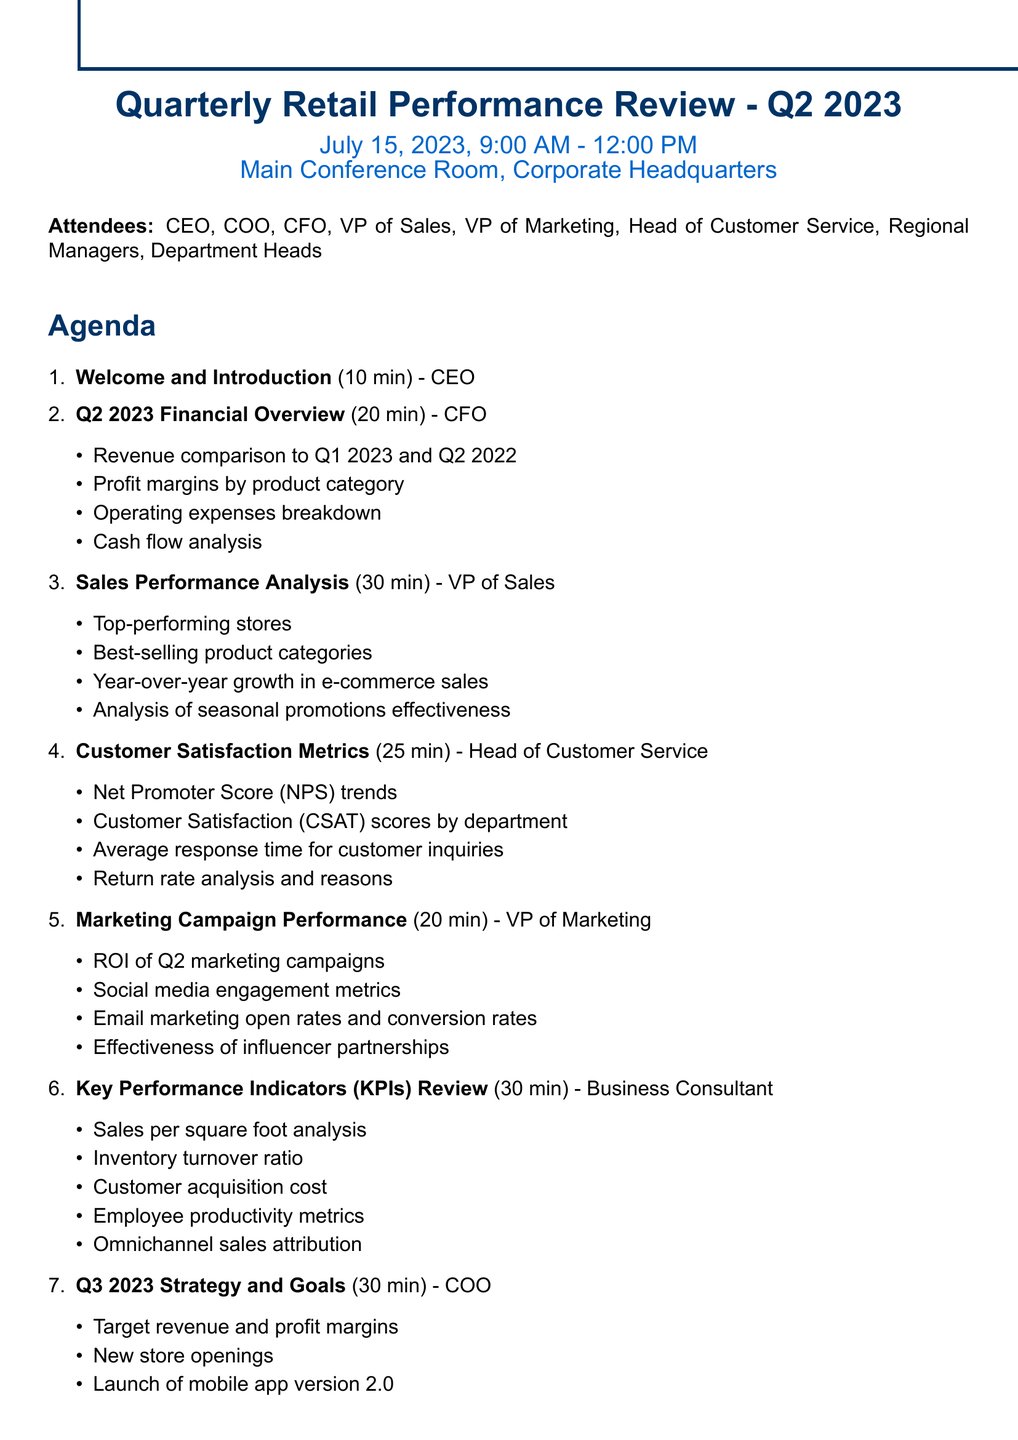What is the title of the meeting? The title of the meeting is presented at the top of the document.
Answer: Quarterly Retail Performance Review - Q2 2023 Who is the presenter for the Sales Performance Analysis? Each agenda item lists a presenter responsible for that section.
Answer: VP of Sales What is the duration of the Q&A and Open Discussion? The duration for each agenda item is specified in the document.
Answer: 15 minutes How many attendees are listed in the document? The number of attendees can be counted from the attendees section.
Answer: 8 What are the top-performing stores mentioned? The VP of Sales highlights specific stores in the Sales Performance Analysis.
Answer: Macy's Herald Square, Nordstrom Michigan Avenue, Bloomingdale's 59th Street What key performance indicator is related to employee metrics? The KPIs Review section lists various metrics, including those related to employee performance.
Answer: Employee productivity metrics What action is assigned to HR? The action items include specific tasks assigned to various departments.
Answer: Schedule training sessions for new POS system Which department head is responsible for the Customer Satisfaction Metrics? Each agenda item specifies the presenter or department head for that topic.
Answer: Head of Customer Service What date is the meeting scheduled for? The meeting date is mentioned right after the title of the meeting.
Answer: July 15, 2023 